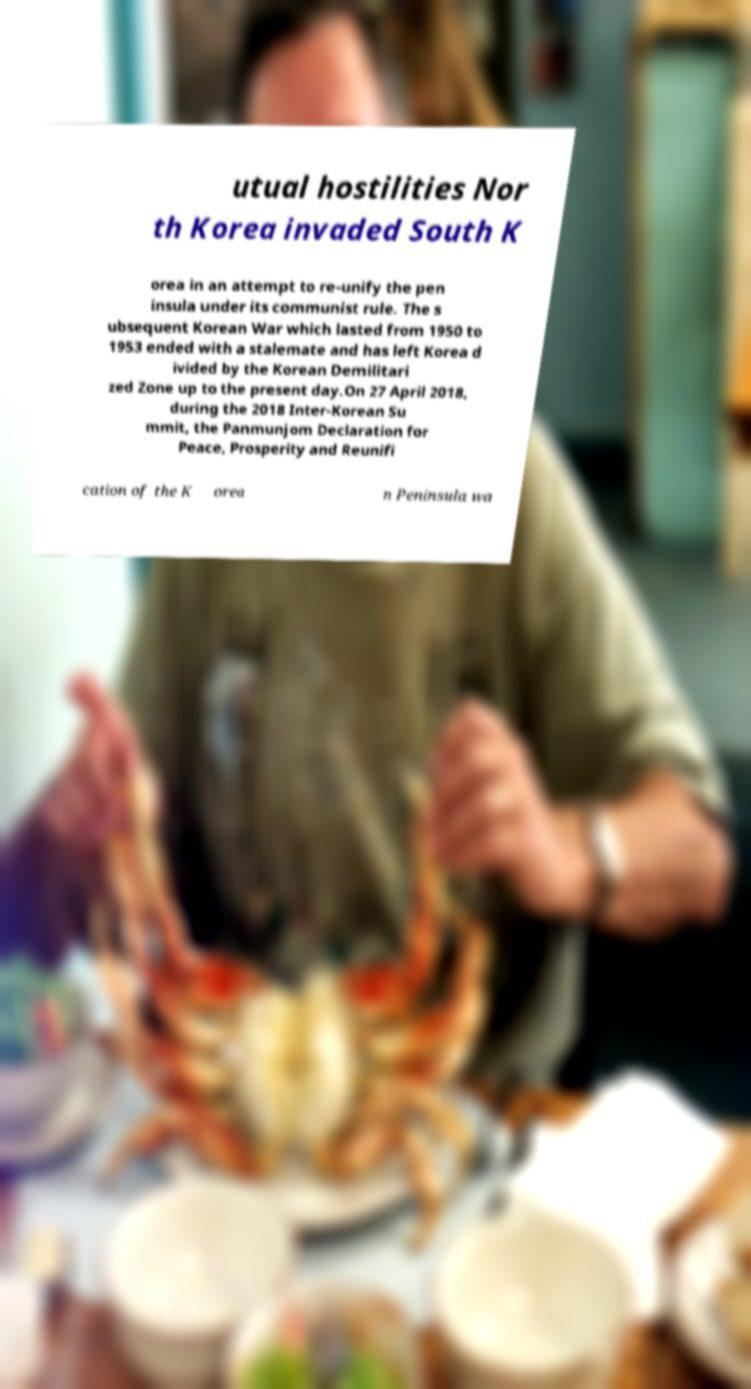There's text embedded in this image that I need extracted. Can you transcribe it verbatim? utual hostilities Nor th Korea invaded South K orea in an attempt to re-unify the pen insula under its communist rule. The s ubsequent Korean War which lasted from 1950 to 1953 ended with a stalemate and has left Korea d ivided by the Korean Demilitari zed Zone up to the present day.On 27 April 2018, during the 2018 Inter-Korean Su mmit, the Panmunjom Declaration for Peace, Prosperity and Reunifi cation of the K orea n Peninsula wa 